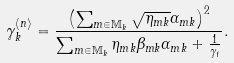<formula> <loc_0><loc_0><loc_500><loc_500>\gamma _ { k } ^ { \langle n \rangle } = \frac { \left ( \sum _ { m \in \mathbb { M } _ { k } } \sqrt { \eta _ { m k } } \alpha _ { m k } \right ) ^ { 2 } } { \sum _ { m \in \mathbb { M } _ { k } } \eta _ { m k } \beta _ { m k } \alpha _ { m k } + \frac { 1 } { \gamma _ { t } } } .</formula> 